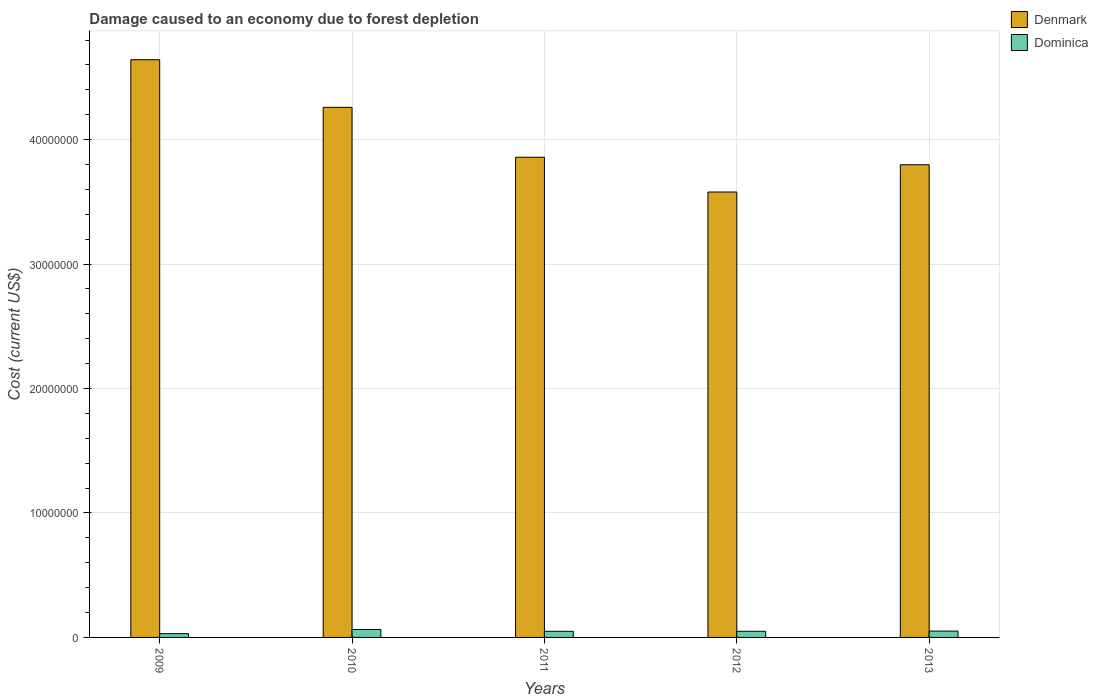Are the number of bars per tick equal to the number of legend labels?
Your answer should be compact. Yes. What is the label of the 2nd group of bars from the left?
Make the answer very short. 2010. What is the cost of damage caused due to forest depletion in Dominica in 2009?
Offer a very short reply. 3.04e+05. Across all years, what is the maximum cost of damage caused due to forest depletion in Dominica?
Give a very brief answer. 6.37e+05. Across all years, what is the minimum cost of damage caused due to forest depletion in Denmark?
Offer a terse response. 3.58e+07. In which year was the cost of damage caused due to forest depletion in Dominica maximum?
Provide a short and direct response. 2010. What is the total cost of damage caused due to forest depletion in Dominica in the graph?
Provide a short and direct response. 2.44e+06. What is the difference between the cost of damage caused due to forest depletion in Denmark in 2009 and that in 2012?
Keep it short and to the point. 1.06e+07. What is the difference between the cost of damage caused due to forest depletion in Denmark in 2011 and the cost of damage caused due to forest depletion in Dominica in 2012?
Your answer should be very brief. 3.81e+07. What is the average cost of damage caused due to forest depletion in Dominica per year?
Offer a very short reply. 4.88e+05. In the year 2009, what is the difference between the cost of damage caused due to forest depletion in Dominica and cost of damage caused due to forest depletion in Denmark?
Make the answer very short. -4.61e+07. In how many years, is the cost of damage caused due to forest depletion in Denmark greater than 34000000 US$?
Provide a short and direct response. 5. What is the ratio of the cost of damage caused due to forest depletion in Denmark in 2009 to that in 2010?
Offer a terse response. 1.09. What is the difference between the highest and the second highest cost of damage caused due to forest depletion in Denmark?
Ensure brevity in your answer.  3.83e+06. What is the difference between the highest and the lowest cost of damage caused due to forest depletion in Dominica?
Your answer should be compact. 3.33e+05. Is the sum of the cost of damage caused due to forest depletion in Denmark in 2012 and 2013 greater than the maximum cost of damage caused due to forest depletion in Dominica across all years?
Your answer should be very brief. Yes. What does the 2nd bar from the right in 2013 represents?
Make the answer very short. Denmark. How many bars are there?
Keep it short and to the point. 10. Where does the legend appear in the graph?
Ensure brevity in your answer.  Top right. How are the legend labels stacked?
Make the answer very short. Vertical. What is the title of the graph?
Provide a short and direct response. Damage caused to an economy due to forest depletion. Does "Croatia" appear as one of the legend labels in the graph?
Offer a terse response. No. What is the label or title of the X-axis?
Provide a succinct answer. Years. What is the label or title of the Y-axis?
Ensure brevity in your answer.  Cost (current US$). What is the Cost (current US$) of Denmark in 2009?
Ensure brevity in your answer.  4.64e+07. What is the Cost (current US$) in Dominica in 2009?
Offer a very short reply. 3.04e+05. What is the Cost (current US$) of Denmark in 2010?
Make the answer very short. 4.26e+07. What is the Cost (current US$) in Dominica in 2010?
Your response must be concise. 6.37e+05. What is the Cost (current US$) of Denmark in 2011?
Your answer should be very brief. 3.86e+07. What is the Cost (current US$) in Dominica in 2011?
Keep it short and to the point. 4.94e+05. What is the Cost (current US$) of Denmark in 2012?
Your response must be concise. 3.58e+07. What is the Cost (current US$) in Dominica in 2012?
Offer a terse response. 4.94e+05. What is the Cost (current US$) of Denmark in 2013?
Your response must be concise. 3.80e+07. What is the Cost (current US$) in Dominica in 2013?
Make the answer very short. 5.10e+05. Across all years, what is the maximum Cost (current US$) of Denmark?
Your answer should be very brief. 4.64e+07. Across all years, what is the maximum Cost (current US$) of Dominica?
Provide a succinct answer. 6.37e+05. Across all years, what is the minimum Cost (current US$) in Denmark?
Offer a terse response. 3.58e+07. Across all years, what is the minimum Cost (current US$) in Dominica?
Ensure brevity in your answer.  3.04e+05. What is the total Cost (current US$) of Denmark in the graph?
Ensure brevity in your answer.  2.01e+08. What is the total Cost (current US$) in Dominica in the graph?
Keep it short and to the point. 2.44e+06. What is the difference between the Cost (current US$) in Denmark in 2009 and that in 2010?
Offer a terse response. 3.83e+06. What is the difference between the Cost (current US$) of Dominica in 2009 and that in 2010?
Offer a very short reply. -3.33e+05. What is the difference between the Cost (current US$) of Denmark in 2009 and that in 2011?
Offer a very short reply. 7.84e+06. What is the difference between the Cost (current US$) in Dominica in 2009 and that in 2011?
Give a very brief answer. -1.90e+05. What is the difference between the Cost (current US$) of Denmark in 2009 and that in 2012?
Provide a succinct answer. 1.06e+07. What is the difference between the Cost (current US$) in Dominica in 2009 and that in 2012?
Provide a short and direct response. -1.90e+05. What is the difference between the Cost (current US$) of Denmark in 2009 and that in 2013?
Keep it short and to the point. 8.44e+06. What is the difference between the Cost (current US$) of Dominica in 2009 and that in 2013?
Make the answer very short. -2.06e+05. What is the difference between the Cost (current US$) of Denmark in 2010 and that in 2011?
Provide a short and direct response. 4.01e+06. What is the difference between the Cost (current US$) of Dominica in 2010 and that in 2011?
Ensure brevity in your answer.  1.44e+05. What is the difference between the Cost (current US$) of Denmark in 2010 and that in 2012?
Provide a short and direct response. 6.80e+06. What is the difference between the Cost (current US$) in Dominica in 2010 and that in 2012?
Provide a succinct answer. 1.43e+05. What is the difference between the Cost (current US$) in Denmark in 2010 and that in 2013?
Your response must be concise. 4.61e+06. What is the difference between the Cost (current US$) in Dominica in 2010 and that in 2013?
Provide a short and direct response. 1.27e+05. What is the difference between the Cost (current US$) in Denmark in 2011 and that in 2012?
Keep it short and to the point. 2.79e+06. What is the difference between the Cost (current US$) of Dominica in 2011 and that in 2012?
Your response must be concise. -519.05. What is the difference between the Cost (current US$) in Denmark in 2011 and that in 2013?
Keep it short and to the point. 6.02e+05. What is the difference between the Cost (current US$) of Dominica in 2011 and that in 2013?
Offer a terse response. -1.61e+04. What is the difference between the Cost (current US$) in Denmark in 2012 and that in 2013?
Your response must be concise. -2.19e+06. What is the difference between the Cost (current US$) of Dominica in 2012 and that in 2013?
Give a very brief answer. -1.56e+04. What is the difference between the Cost (current US$) of Denmark in 2009 and the Cost (current US$) of Dominica in 2010?
Offer a very short reply. 4.58e+07. What is the difference between the Cost (current US$) of Denmark in 2009 and the Cost (current US$) of Dominica in 2011?
Offer a terse response. 4.59e+07. What is the difference between the Cost (current US$) of Denmark in 2009 and the Cost (current US$) of Dominica in 2012?
Give a very brief answer. 4.59e+07. What is the difference between the Cost (current US$) of Denmark in 2009 and the Cost (current US$) of Dominica in 2013?
Provide a short and direct response. 4.59e+07. What is the difference between the Cost (current US$) of Denmark in 2010 and the Cost (current US$) of Dominica in 2011?
Give a very brief answer. 4.21e+07. What is the difference between the Cost (current US$) of Denmark in 2010 and the Cost (current US$) of Dominica in 2012?
Your response must be concise. 4.21e+07. What is the difference between the Cost (current US$) in Denmark in 2010 and the Cost (current US$) in Dominica in 2013?
Offer a very short reply. 4.21e+07. What is the difference between the Cost (current US$) of Denmark in 2011 and the Cost (current US$) of Dominica in 2012?
Your response must be concise. 3.81e+07. What is the difference between the Cost (current US$) in Denmark in 2011 and the Cost (current US$) in Dominica in 2013?
Your answer should be compact. 3.81e+07. What is the difference between the Cost (current US$) of Denmark in 2012 and the Cost (current US$) of Dominica in 2013?
Give a very brief answer. 3.53e+07. What is the average Cost (current US$) of Denmark per year?
Offer a terse response. 4.03e+07. What is the average Cost (current US$) in Dominica per year?
Provide a succinct answer. 4.88e+05. In the year 2009, what is the difference between the Cost (current US$) in Denmark and Cost (current US$) in Dominica?
Offer a very short reply. 4.61e+07. In the year 2010, what is the difference between the Cost (current US$) of Denmark and Cost (current US$) of Dominica?
Your answer should be very brief. 4.20e+07. In the year 2011, what is the difference between the Cost (current US$) of Denmark and Cost (current US$) of Dominica?
Make the answer very short. 3.81e+07. In the year 2012, what is the difference between the Cost (current US$) of Denmark and Cost (current US$) of Dominica?
Offer a very short reply. 3.53e+07. In the year 2013, what is the difference between the Cost (current US$) in Denmark and Cost (current US$) in Dominica?
Your answer should be compact. 3.75e+07. What is the ratio of the Cost (current US$) of Denmark in 2009 to that in 2010?
Keep it short and to the point. 1.09. What is the ratio of the Cost (current US$) of Dominica in 2009 to that in 2010?
Keep it short and to the point. 0.48. What is the ratio of the Cost (current US$) in Denmark in 2009 to that in 2011?
Your answer should be compact. 1.2. What is the ratio of the Cost (current US$) in Dominica in 2009 to that in 2011?
Provide a succinct answer. 0.62. What is the ratio of the Cost (current US$) of Denmark in 2009 to that in 2012?
Keep it short and to the point. 1.3. What is the ratio of the Cost (current US$) of Dominica in 2009 to that in 2012?
Offer a very short reply. 0.61. What is the ratio of the Cost (current US$) in Denmark in 2009 to that in 2013?
Your response must be concise. 1.22. What is the ratio of the Cost (current US$) in Dominica in 2009 to that in 2013?
Keep it short and to the point. 0.6. What is the ratio of the Cost (current US$) of Denmark in 2010 to that in 2011?
Make the answer very short. 1.1. What is the ratio of the Cost (current US$) in Dominica in 2010 to that in 2011?
Offer a very short reply. 1.29. What is the ratio of the Cost (current US$) in Denmark in 2010 to that in 2012?
Keep it short and to the point. 1.19. What is the ratio of the Cost (current US$) in Dominica in 2010 to that in 2012?
Provide a succinct answer. 1.29. What is the ratio of the Cost (current US$) of Denmark in 2010 to that in 2013?
Give a very brief answer. 1.12. What is the ratio of the Cost (current US$) in Denmark in 2011 to that in 2012?
Provide a short and direct response. 1.08. What is the ratio of the Cost (current US$) in Dominica in 2011 to that in 2012?
Make the answer very short. 1. What is the ratio of the Cost (current US$) of Denmark in 2011 to that in 2013?
Keep it short and to the point. 1.02. What is the ratio of the Cost (current US$) in Dominica in 2011 to that in 2013?
Ensure brevity in your answer.  0.97. What is the ratio of the Cost (current US$) of Denmark in 2012 to that in 2013?
Your answer should be very brief. 0.94. What is the ratio of the Cost (current US$) of Dominica in 2012 to that in 2013?
Ensure brevity in your answer.  0.97. What is the difference between the highest and the second highest Cost (current US$) in Denmark?
Your response must be concise. 3.83e+06. What is the difference between the highest and the second highest Cost (current US$) of Dominica?
Make the answer very short. 1.27e+05. What is the difference between the highest and the lowest Cost (current US$) of Denmark?
Give a very brief answer. 1.06e+07. What is the difference between the highest and the lowest Cost (current US$) of Dominica?
Provide a short and direct response. 3.33e+05. 